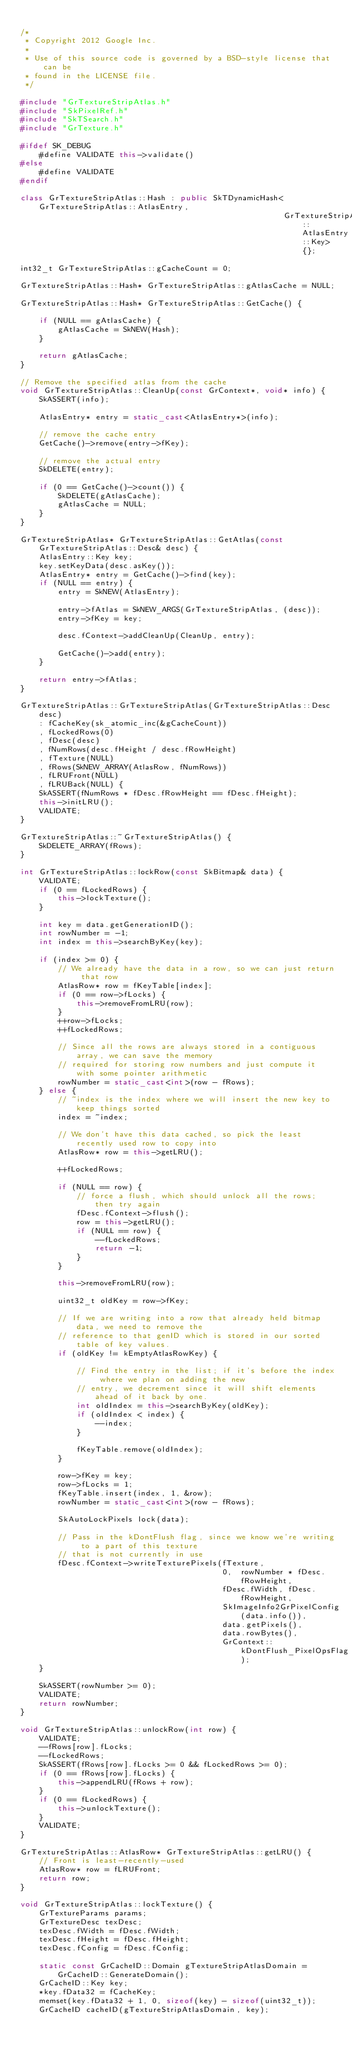Convert code to text. <code><loc_0><loc_0><loc_500><loc_500><_C++_>
/*
 * Copyright 2012 Google Inc.
 *
 * Use of this source code is governed by a BSD-style license that can be
 * found in the LICENSE file.
 */

#include "GrTextureStripAtlas.h"
#include "SkPixelRef.h"
#include "SkTSearch.h"
#include "GrTexture.h"

#ifdef SK_DEBUG
    #define VALIDATE this->validate()
#else
    #define VALIDATE
#endif

class GrTextureStripAtlas::Hash : public SkTDynamicHash<GrTextureStripAtlas::AtlasEntry, 
                                                        GrTextureStripAtlas::AtlasEntry::Key> {};

int32_t GrTextureStripAtlas::gCacheCount = 0;

GrTextureStripAtlas::Hash* GrTextureStripAtlas::gAtlasCache = NULL;

GrTextureStripAtlas::Hash* GrTextureStripAtlas::GetCache() {

    if (NULL == gAtlasCache) {
        gAtlasCache = SkNEW(Hash);
    }

    return gAtlasCache;
}

// Remove the specified atlas from the cache
void GrTextureStripAtlas::CleanUp(const GrContext*, void* info) {
    SkASSERT(info);

    AtlasEntry* entry = static_cast<AtlasEntry*>(info);

    // remove the cache entry
    GetCache()->remove(entry->fKey);

    // remove the actual entry
    SkDELETE(entry);

    if (0 == GetCache()->count()) {
        SkDELETE(gAtlasCache);
        gAtlasCache = NULL;
    }
}

GrTextureStripAtlas* GrTextureStripAtlas::GetAtlas(const GrTextureStripAtlas::Desc& desc) {
    AtlasEntry::Key key;
    key.setKeyData(desc.asKey());
    AtlasEntry* entry = GetCache()->find(key);
    if (NULL == entry) {
        entry = SkNEW(AtlasEntry);

        entry->fAtlas = SkNEW_ARGS(GrTextureStripAtlas, (desc));
        entry->fKey = key;

        desc.fContext->addCleanUp(CleanUp, entry);

        GetCache()->add(entry);
    }

    return entry->fAtlas;
}

GrTextureStripAtlas::GrTextureStripAtlas(GrTextureStripAtlas::Desc desc)
    : fCacheKey(sk_atomic_inc(&gCacheCount))
    , fLockedRows(0)
    , fDesc(desc)
    , fNumRows(desc.fHeight / desc.fRowHeight)
    , fTexture(NULL)
    , fRows(SkNEW_ARRAY(AtlasRow, fNumRows))
    , fLRUFront(NULL)
    , fLRUBack(NULL) {
    SkASSERT(fNumRows * fDesc.fRowHeight == fDesc.fHeight);
    this->initLRU();
    VALIDATE;
}

GrTextureStripAtlas::~GrTextureStripAtlas() {
    SkDELETE_ARRAY(fRows);
}

int GrTextureStripAtlas::lockRow(const SkBitmap& data) {
    VALIDATE;
    if (0 == fLockedRows) {
        this->lockTexture();
    }

    int key = data.getGenerationID();
    int rowNumber = -1;
    int index = this->searchByKey(key);

    if (index >= 0) {
        // We already have the data in a row, so we can just return that row
        AtlasRow* row = fKeyTable[index];
        if (0 == row->fLocks) {
            this->removeFromLRU(row);
        }
        ++row->fLocks;
        ++fLockedRows;

        // Since all the rows are always stored in a contiguous array, we can save the memory
        // required for storing row numbers and just compute it with some pointer arithmetic
        rowNumber = static_cast<int>(row - fRows);
    } else {
        // ~index is the index where we will insert the new key to keep things sorted
        index = ~index;

        // We don't have this data cached, so pick the least recently used row to copy into
        AtlasRow* row = this->getLRU();

        ++fLockedRows;

        if (NULL == row) {
            // force a flush, which should unlock all the rows; then try again
            fDesc.fContext->flush();
            row = this->getLRU();
            if (NULL == row) {
                --fLockedRows;
                return -1;
            }
        }

        this->removeFromLRU(row);

        uint32_t oldKey = row->fKey;

        // If we are writing into a row that already held bitmap data, we need to remove the
        // reference to that genID which is stored in our sorted table of key values.
        if (oldKey != kEmptyAtlasRowKey) {

            // Find the entry in the list; if it's before the index where we plan on adding the new
            // entry, we decrement since it will shift elements ahead of it back by one.
            int oldIndex = this->searchByKey(oldKey);
            if (oldIndex < index) {
                --index;
            }

            fKeyTable.remove(oldIndex);
        }

        row->fKey = key;
        row->fLocks = 1;
        fKeyTable.insert(index, 1, &row);
        rowNumber = static_cast<int>(row - fRows);

        SkAutoLockPixels lock(data);

        // Pass in the kDontFlush flag, since we know we're writing to a part of this texture
        // that is not currently in use
        fDesc.fContext->writeTexturePixels(fTexture,
                                           0,  rowNumber * fDesc.fRowHeight,
                                           fDesc.fWidth, fDesc.fRowHeight,
                                           SkImageInfo2GrPixelConfig(data.info()),
                                           data.getPixels(),
                                           data.rowBytes(),
                                           GrContext::kDontFlush_PixelOpsFlag);
    }

    SkASSERT(rowNumber >= 0);
    VALIDATE;
    return rowNumber;
}

void GrTextureStripAtlas::unlockRow(int row) {
    VALIDATE;
    --fRows[row].fLocks;
    --fLockedRows;
    SkASSERT(fRows[row].fLocks >= 0 && fLockedRows >= 0);
    if (0 == fRows[row].fLocks) {
        this->appendLRU(fRows + row);
    }
    if (0 == fLockedRows) {
        this->unlockTexture();
    }
    VALIDATE;
}

GrTextureStripAtlas::AtlasRow* GrTextureStripAtlas::getLRU() {
    // Front is least-recently-used
    AtlasRow* row = fLRUFront;
    return row;
}

void GrTextureStripAtlas::lockTexture() {
    GrTextureParams params;
    GrTextureDesc texDesc;
    texDesc.fWidth = fDesc.fWidth;
    texDesc.fHeight = fDesc.fHeight;
    texDesc.fConfig = fDesc.fConfig;

    static const GrCacheID::Domain gTextureStripAtlasDomain = GrCacheID::GenerateDomain();
    GrCacheID::Key key;
    *key.fData32 = fCacheKey;
    memset(key.fData32 + 1, 0, sizeof(key) - sizeof(uint32_t));
    GrCacheID cacheID(gTextureStripAtlasDomain, key);
</code> 